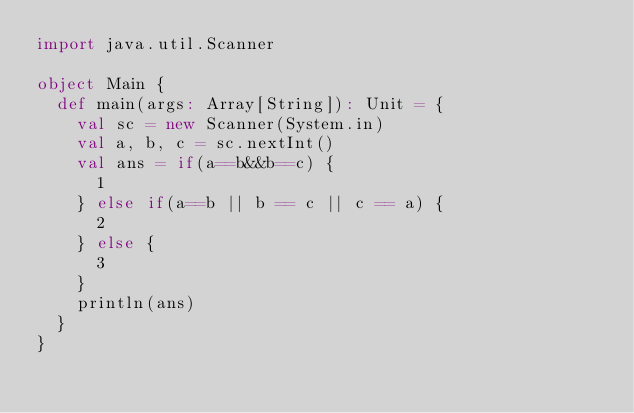Convert code to text. <code><loc_0><loc_0><loc_500><loc_500><_Scala_>import java.util.Scanner

object Main {
  def main(args: Array[String]): Unit = {
    val sc = new Scanner(System.in)
    val a, b, c = sc.nextInt()
    val ans = if(a==b&&b==c) {
      1
    } else if(a==b || b == c || c == a) {
      2
    } else {
      3
    }
    println(ans)
  }
}
</code> 